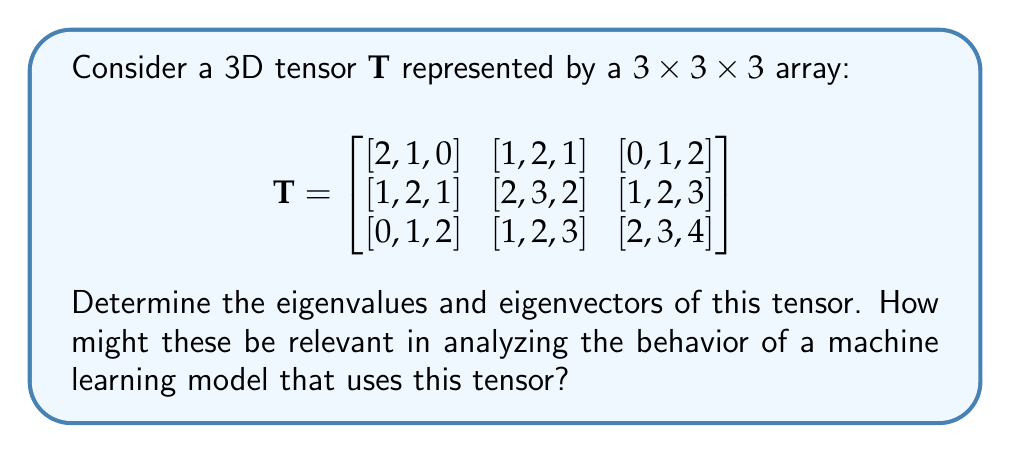Teach me how to tackle this problem. To find the eigenvalues and eigenvectors of a 3D tensor, we need to follow these steps:

1) First, we need to matricize the tensor. For a 3D tensor, there are three possible matricizations. Let's use the mode-1 matricization, which unfolds the tensor along the first dimension:

$$\mathbf{T}_{(1)} = \begin{bmatrix}
2 & 1 & 0 & 1 & 2 & 1 & 0 & 1 & 2 \\
1 & 2 & 1 & 2 & 3 & 2 & 1 & 2 & 3 \\
0 & 1 & 2 & 1 & 2 & 3 & 2 & 3 & 4
\end{bmatrix}$$

2) Now, we need to find the eigenvalues and eigenvectors of $\mathbf{T}_{(1)}\mathbf{T}_{(1)}^T$:

$$\mathbf{T}_{(1)}\mathbf{T}_{(1)}^T = \begin{bmatrix}
20 & 24 & 21 \\
24 & 36 & 33 \\
21 & 33 & 35
\end{bmatrix}$$

3) To find the eigenvalues, we solve the characteristic equation:

$$\det(\mathbf{T}_{(1)}\mathbf{T}_{(1)}^T - \lambda \mathbf{I}) = 0$$

This gives us the cubic equation:

$$-\lambda^3 + 91\lambda^2 - 2070\lambda + 9900 = 0$$

4) Solving this equation (using numerical methods), we get the eigenvalues:

$$\lambda_1 \approx 82.8954, \lambda_2 \approx 7.7046, \lambda_3 \approx 0.4000$$

5) For each eigenvalue, we can find the corresponding eigenvector by solving:

$$(\mathbf{T}_{(1)}\mathbf{T}_{(1)}^T - \lambda_i \mathbf{I})\mathbf{v}_i = \mathbf{0}$$

6) This gives us the eigenvectors (normalized):

$$\mathbf{v}_1 \approx [0.4684, 0.6330, 0.6164]^T$$
$$\mathbf{v}_2 \approx [-0.8783, 0.2129, 0.4289]^T$$
$$\mathbf{v}_3 \approx [0.0968, -0.7448, 0.6605]^T$$

In machine learning, these eigenvalues and eigenvectors can be used to understand the principal components of the data represented by the tensor. The largest eigenvalue and its corresponding eigenvector indicate the direction of maximum variance in the data, which can be crucial for dimensionality reduction techniques like PCA or for understanding the most important features in a model.
Answer: Eigenvalues: $\lambda_1 \approx 82.8954, \lambda_2 \approx 7.7046, \lambda_3 \approx 0.4000$
Eigenvectors: $\mathbf{v}_1 \approx [0.4684, 0.6330, 0.6164]^T, \mathbf{v}_2 \approx [-0.8783, 0.2129, 0.4289]^T, \mathbf{v}_3 \approx [0.0968, -0.7448, 0.6605]^T$ 